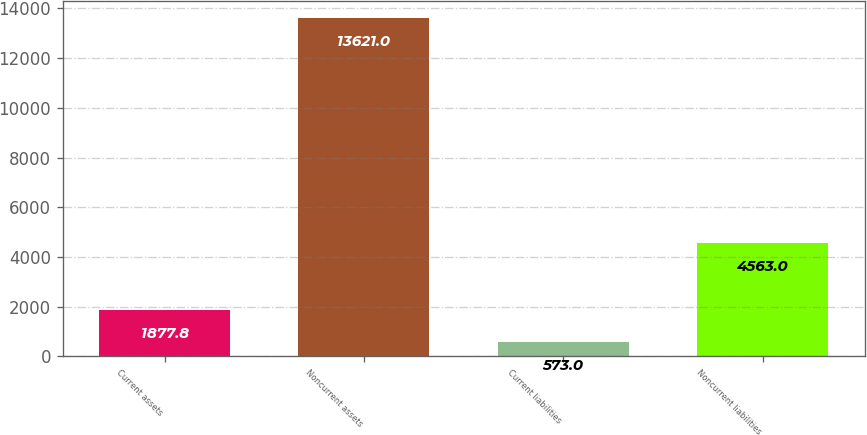Convert chart to OTSL. <chart><loc_0><loc_0><loc_500><loc_500><bar_chart><fcel>Current assets<fcel>Noncurrent assets<fcel>Current liabilities<fcel>Noncurrent liabilities<nl><fcel>1877.8<fcel>13621<fcel>573<fcel>4563<nl></chart> 